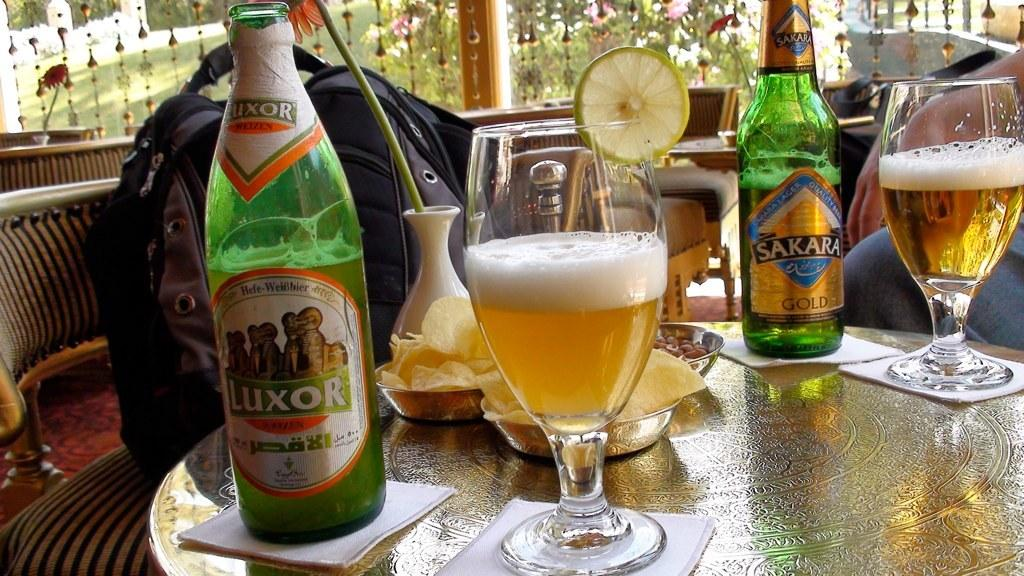<image>
Offer a succinct explanation of the picture presented. Bottles of beer and glases filled with the beer labelled Luxor. 